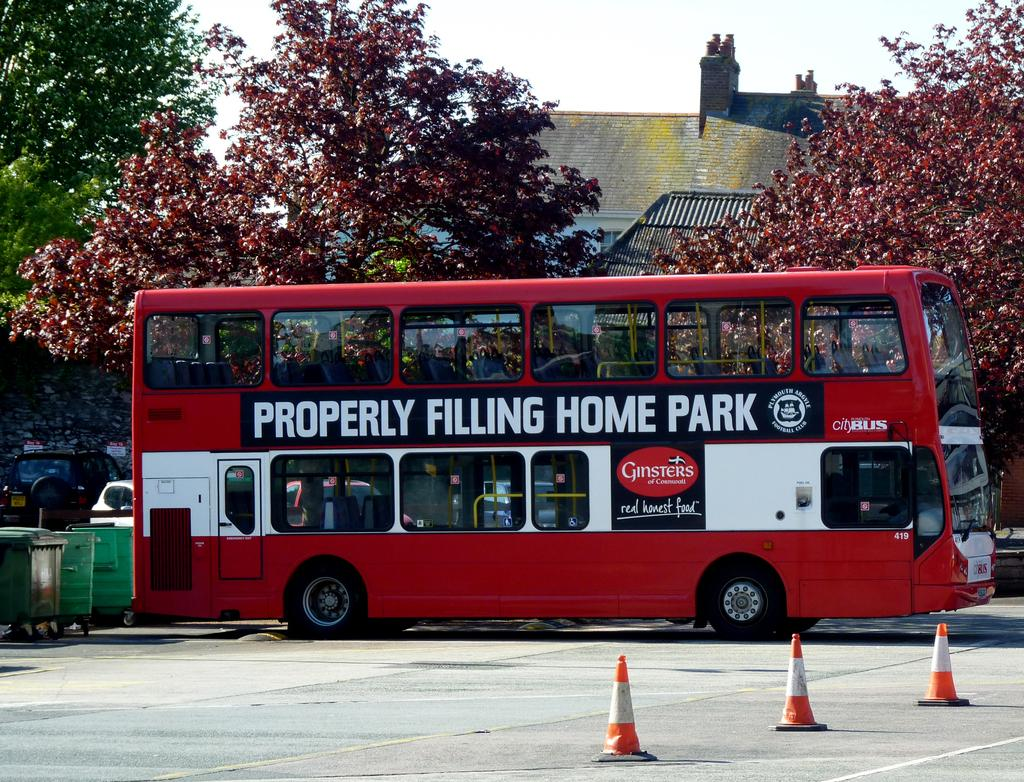What type of vehicle can be seen on the road in the image? There is a bus on the road in the image. What structures are present along the road in the image? There are traffic poles in the image. What objects can be seen near the road in the image? There are containers in the image. What other type of vehicle is present in the image? There is a car in the image. What type of vegetation is visible in the image? There is a group of trees in the image. What type of building is visible in the image? There is a house with a roof in the image. What is visible in the sky in the image? The sky is visible in the image and appears cloudy. How many crackers are being used to measure the distance between the bus and the car in the image? There are no crackers present in the image, and they are not being used to measure any distances. What type of work is being done by the trees in the image? The trees are not performing any work in the image; they are simply a part of the natural landscape. 